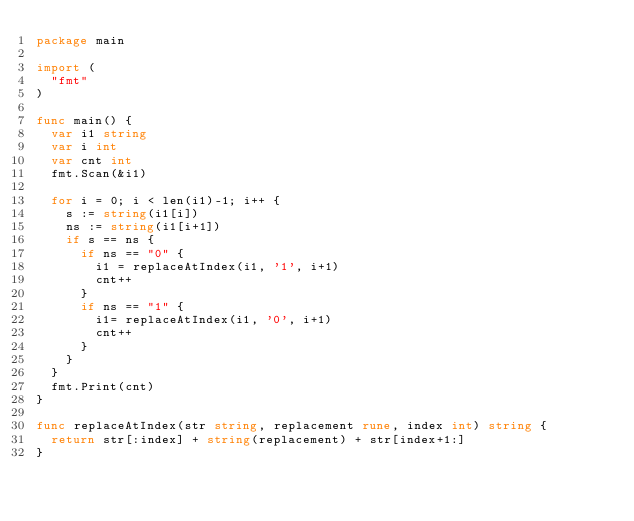<code> <loc_0><loc_0><loc_500><loc_500><_Go_>package main

import (
	"fmt"
)

func main() {
	var i1 string
	var i int
	var cnt int
	fmt.Scan(&i1)

	for i = 0; i < len(i1)-1; i++ {
		s := string(i1[i])
		ns := string(i1[i+1])
		if s == ns {
			if ns == "0" {
				i1 = replaceAtIndex(i1, '1', i+1)
				cnt++
			}
			if ns == "1" {
				i1= replaceAtIndex(i1, '0', i+1)
				cnt++
			}
		}
	}
	fmt.Print(cnt)
}

func replaceAtIndex(str string, replacement rune, index int) string {
	return str[:index] + string(replacement) + str[index+1:]
}</code> 